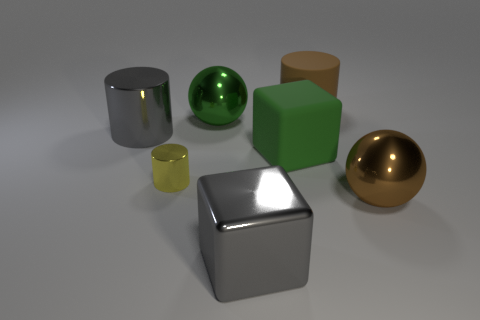Is there another large metallic object that has the same shape as the big brown shiny thing?
Provide a succinct answer. Yes. The big thing that is left of the tiny yellow shiny cylinder has what shape?
Offer a terse response. Cylinder. There is a large block that is in front of the tiny metallic cylinder in front of the big green rubber object; what number of large objects are on the left side of it?
Make the answer very short. 2. Do the metal thing that is left of the small yellow cylinder and the tiny metal cylinder have the same color?
Give a very brief answer. No. What number of other things are there of the same shape as the green rubber thing?
Your answer should be very brief. 1. What number of other things are made of the same material as the tiny yellow thing?
Your response must be concise. 4. There is a big green object in front of the gray metal thing that is behind the shiny thing in front of the brown metal object; what is its material?
Offer a very short reply. Rubber. Do the big gray cube and the tiny yellow cylinder have the same material?
Offer a terse response. Yes. What number of cylinders are either rubber objects or yellow metallic things?
Your response must be concise. 2. What color is the shiny sphere that is on the left side of the brown sphere?
Offer a very short reply. Green. 